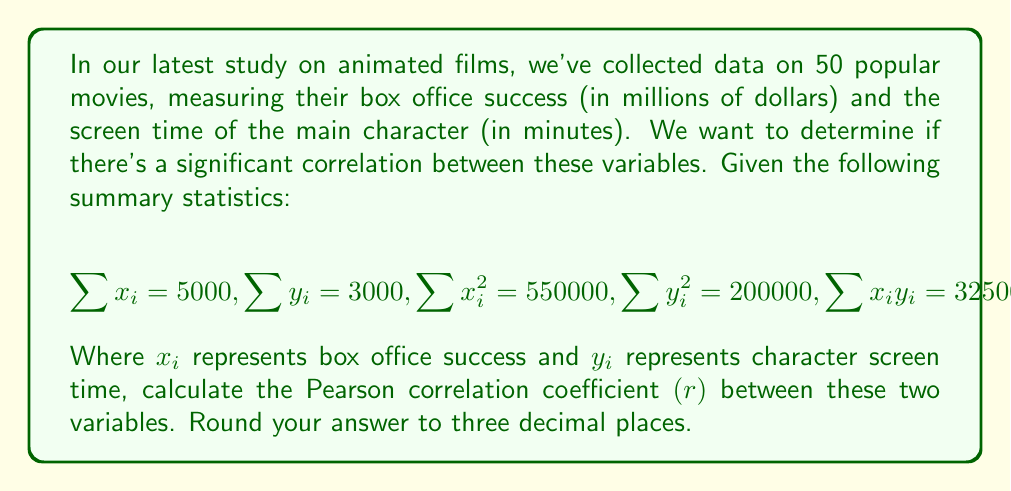What is the answer to this math problem? To calculate the Pearson correlation coefficient $(r)$, we'll use the formula:

$$r = \frac{n\sum x_iy_i - \sum x_i \sum y_i}{\sqrt{[n\sum x_i^2 - (\sum x_i)^2][n\sum y_i^2 - (\sum y_i)^2]}}$$

Where $n$ is the number of movies (50 in this case).

Let's break it down step by step:

1) First, calculate the numerator:
   $50(325000) - (5000)(3000) = 16250000 - 15000000 = 1250000$

2) Now, let's calculate the two parts of the denominator:
   For $x$: $50(550000) - (5000)^2 = 27500000 - 25000000 = 2500000$
   For $y$: $50(200000) - (3000)^2 = 10000000 - 9000000 = 1000000$

3) Multiply these parts:
   $2500000 * 1000000 = 2.5 * 10^{12}$

4) Take the square root:
   $\sqrt{2.5 * 10^{12}} = 1581138.83$

5) Now we can put it all together:
   $r = \frac{1250000}{1581138.83} = 0.7905691$

6) Rounding to three decimal places:
   $r \approx 0.791$
Answer: $r \approx 0.791$ 